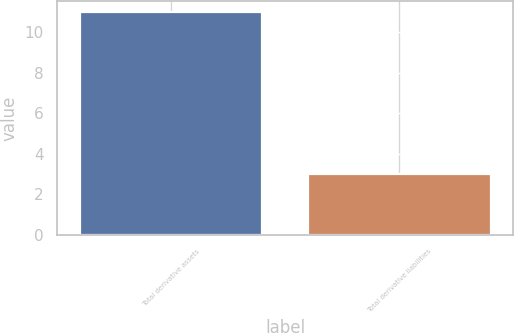Convert chart. <chart><loc_0><loc_0><loc_500><loc_500><bar_chart><fcel>Total derivative assets<fcel>Total derivative liabilities<nl><fcel>11<fcel>3<nl></chart> 